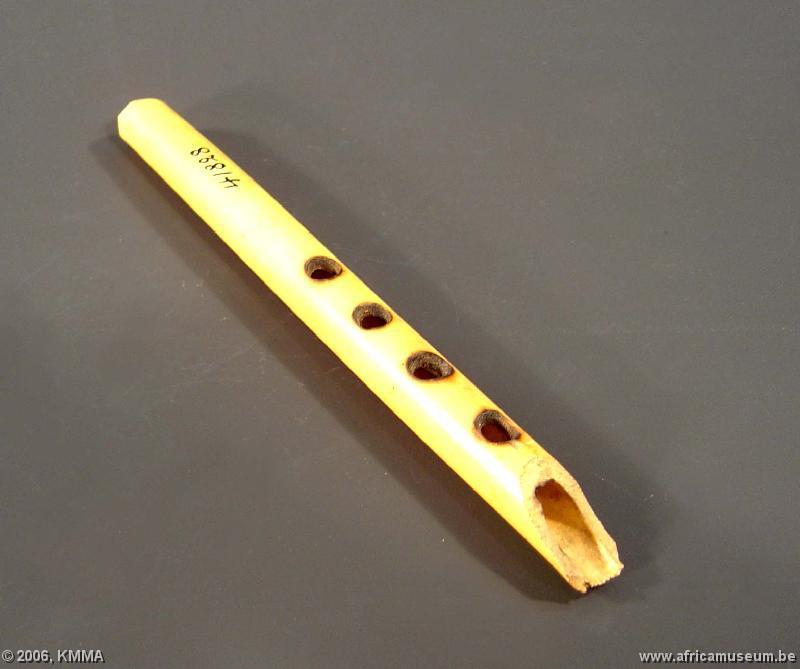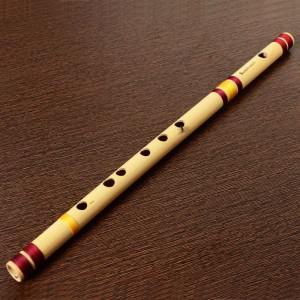The first image is the image on the left, the second image is the image on the right. For the images displayed, is the sentence "Two light colored flutes sit side by side." factually correct? Answer yes or no. No. The first image is the image on the left, the second image is the image on the right. Analyze the images presented: Is the assertion "One image shows a single flute displayed diagonally, and the other image shows at least two flutes displayed right next to each other diagonally." valid? Answer yes or no. No. 